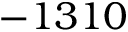Convert formula to latex. <formula><loc_0><loc_0><loc_500><loc_500>- 1 3 1 0</formula> 